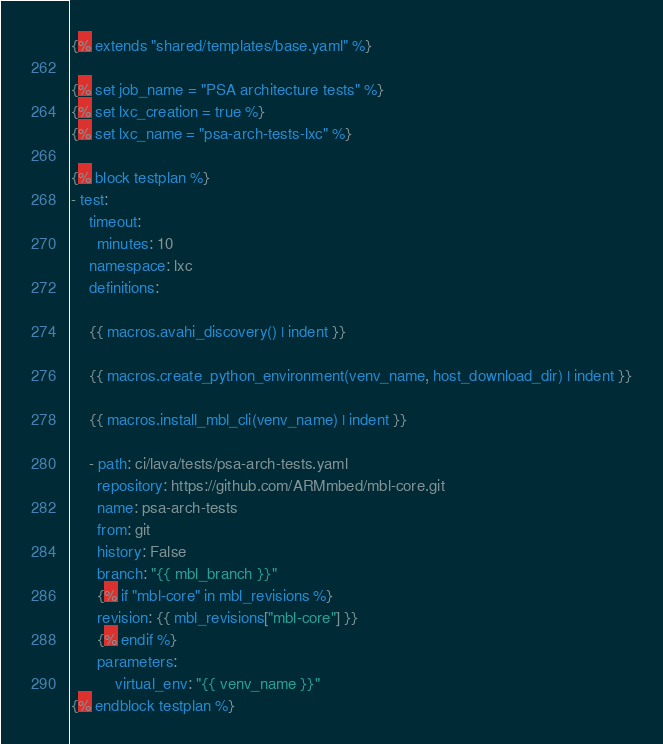Convert code to text. <code><loc_0><loc_0><loc_500><loc_500><_YAML_>{% extends "shared/templates/base.yaml" %}

{% set job_name = "PSA architecture tests" %}
{% set lxc_creation = true %}
{% set lxc_name = "psa-arch-tests-lxc" %}

{% block testplan %}
- test:
    timeout:
      minutes: 10
    namespace: lxc
    definitions:

    {{ macros.avahi_discovery() | indent }}

    {{ macros.create_python_environment(venv_name, host_download_dir) | indent }}

    {{ macros.install_mbl_cli(venv_name) | indent }}

    - path: ci/lava/tests/psa-arch-tests.yaml
      repository: https://github.com/ARMmbed/mbl-core.git
      name: psa-arch-tests
      from: git
      history: False
      branch: "{{ mbl_branch }}"
      {% if "mbl-core" in mbl_revisions %}
      revision: {{ mbl_revisions["mbl-core"] }}
      {% endif %}
      parameters:
          virtual_env: "{{ venv_name }}"
{% endblock testplan %}

</code> 